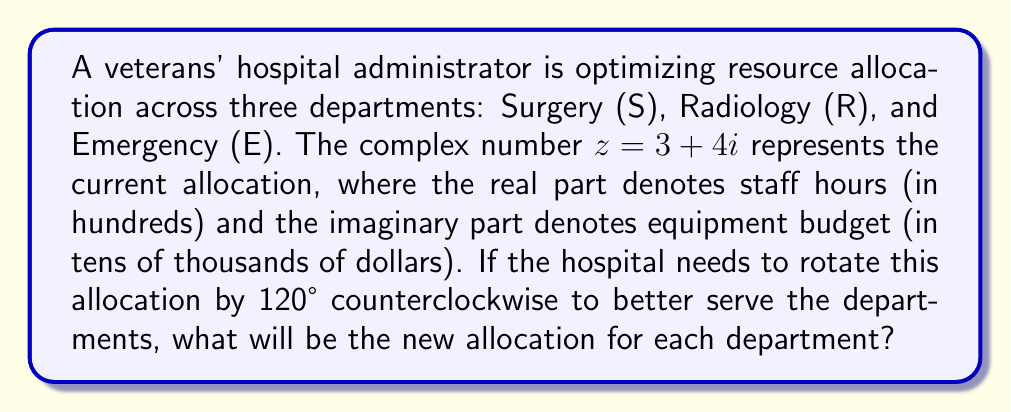Can you answer this question? 1) To rotate a complex number by an angle θ, we multiply it by $e^{iθ}$. In this case, θ = 120° = $\frac{2π}{3}$ radians.

2) $e^{i\frac{2π}{3}} = \cos(\frac{2π}{3}) + i\sin(\frac{2π}{3}) = -\frac{1}{2} + i\frac{\sqrt{3}}{2}$

3) Multiply $z$ by $e^{i\frac{2π}{3}}$:
   $$(3+4i)(-\frac{1}{2} + i\frac{\sqrt{3}}{2}) = (-\frac{3}{2} - 2i\sqrt{3}) + (2\sqrt{3} - 2i)$$
   $$= -\frac{3}{2} + 2\sqrt{3} + (-2\sqrt{3} - 2)i$$
   $$= -\frac{3}{2} + 2\sqrt{3} + (-2\sqrt{3} - 2)i$$

4) Simplify:
   $$z_{new} = -1.5 + 3.464 - 5.464i$$
   $$\approx 1.964 - 5.464i$$

5) Interpret the result:
   Real part: 1.964 hundreds of staff hours ≈ 196 staff hours
   Imaginary part: -5.464 tens of thousands of dollars ≈ -$54,640 for equipment

6) Divide this allocation equally among the three departments:
   Each department gets approximately 65 staff hours and -$18,213 for equipment.

7) The negative budget for equipment suggests a reduction in the equipment budget for each department.
Answer: Each department (S, R, E) receives approximately 65 staff hours and a $18,213 reduction in equipment budget. 